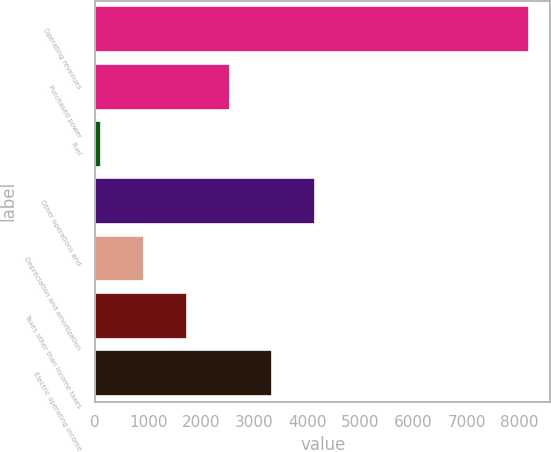Convert chart. <chart><loc_0><loc_0><loc_500><loc_500><bar_chart><fcel>Operating revenues<fcel>Purchased power<fcel>Fuel<fcel>Other operations and<fcel>Depreciation and amortization<fcel>Taxes other than income taxes<fcel>Electric operating income<nl><fcel>8172<fcel>2534.2<fcel>118<fcel>4145<fcel>923.4<fcel>1728.8<fcel>3339.6<nl></chart> 